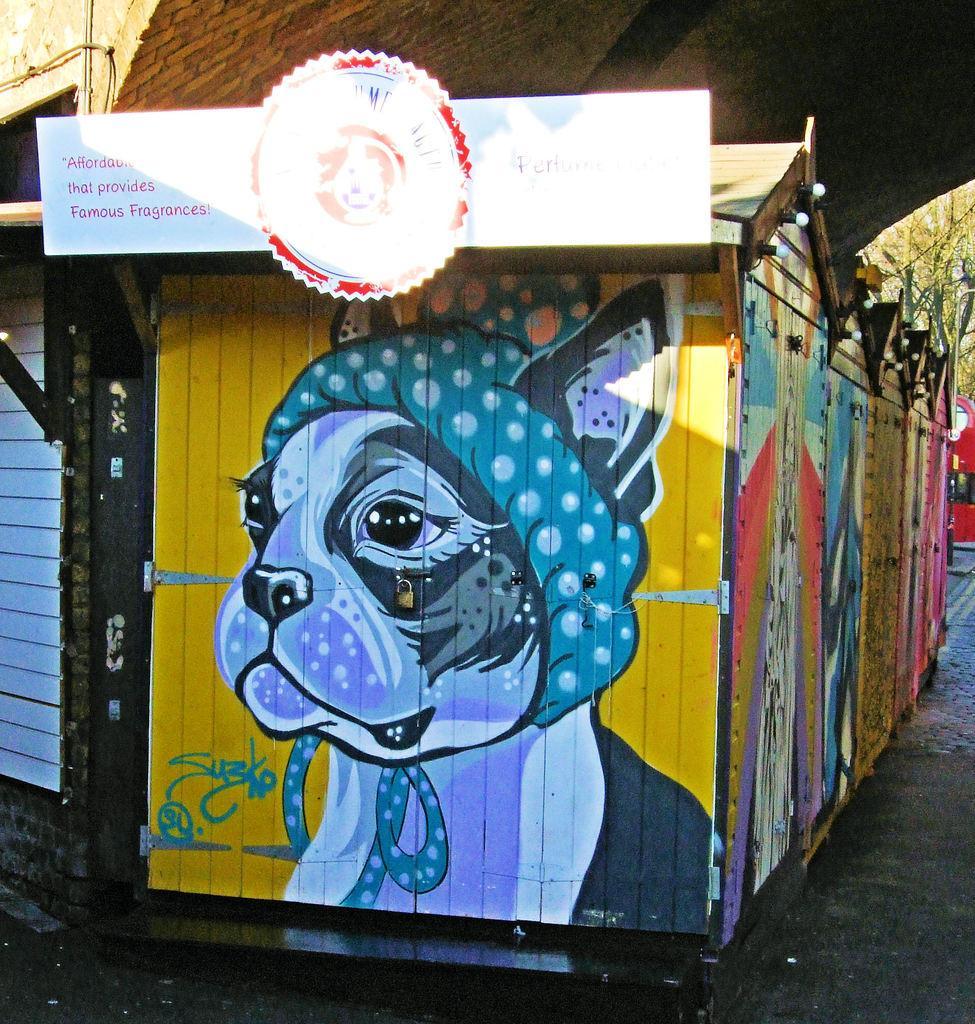In one or two sentences, can you explain what this image depicts? In this image I see few houses on which there is art on it and I see a board over here on which there are few words written and I see the path. In the background I see the trees and the wall. 